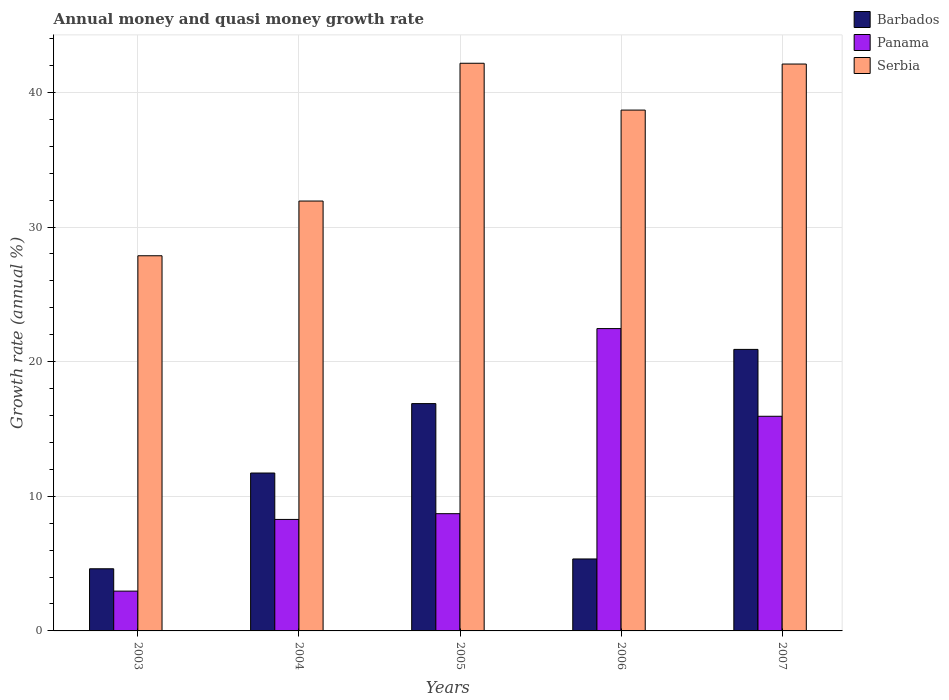How many bars are there on the 5th tick from the left?
Give a very brief answer. 3. In how many cases, is the number of bars for a given year not equal to the number of legend labels?
Offer a terse response. 0. What is the growth rate in Panama in 2006?
Ensure brevity in your answer.  22.46. Across all years, what is the maximum growth rate in Serbia?
Ensure brevity in your answer.  42.17. Across all years, what is the minimum growth rate in Panama?
Give a very brief answer. 2.96. In which year was the growth rate in Panama maximum?
Provide a succinct answer. 2006. In which year was the growth rate in Serbia minimum?
Ensure brevity in your answer.  2003. What is the total growth rate in Barbados in the graph?
Your answer should be very brief. 59.49. What is the difference between the growth rate in Barbados in 2004 and that in 2005?
Offer a very short reply. -5.16. What is the difference between the growth rate in Serbia in 2006 and the growth rate in Panama in 2004?
Your answer should be compact. 30.41. What is the average growth rate in Barbados per year?
Provide a short and direct response. 11.9. In the year 2005, what is the difference between the growth rate in Panama and growth rate in Serbia?
Give a very brief answer. -33.46. In how many years, is the growth rate in Serbia greater than 26 %?
Your answer should be very brief. 5. What is the ratio of the growth rate in Panama in 2004 to that in 2007?
Provide a succinct answer. 0.52. Is the difference between the growth rate in Panama in 2004 and 2005 greater than the difference between the growth rate in Serbia in 2004 and 2005?
Your response must be concise. Yes. What is the difference between the highest and the second highest growth rate in Serbia?
Offer a very short reply. 0.06. What is the difference between the highest and the lowest growth rate in Barbados?
Offer a terse response. 16.3. Is the sum of the growth rate in Barbados in 2003 and 2005 greater than the maximum growth rate in Serbia across all years?
Provide a succinct answer. No. What does the 1st bar from the left in 2005 represents?
Offer a very short reply. Barbados. What does the 1st bar from the right in 2003 represents?
Offer a very short reply. Serbia. Is it the case that in every year, the sum of the growth rate in Barbados and growth rate in Panama is greater than the growth rate in Serbia?
Offer a very short reply. No. How many bars are there?
Keep it short and to the point. 15. What is the difference between two consecutive major ticks on the Y-axis?
Make the answer very short. 10. Are the values on the major ticks of Y-axis written in scientific E-notation?
Your response must be concise. No. Does the graph contain grids?
Your answer should be very brief. Yes. Where does the legend appear in the graph?
Offer a very short reply. Top right. How many legend labels are there?
Your answer should be compact. 3. What is the title of the graph?
Ensure brevity in your answer.  Annual money and quasi money growth rate. What is the label or title of the Y-axis?
Offer a terse response. Growth rate (annual %). What is the Growth rate (annual %) of Barbados in 2003?
Keep it short and to the point. 4.62. What is the Growth rate (annual %) of Panama in 2003?
Offer a terse response. 2.96. What is the Growth rate (annual %) of Serbia in 2003?
Make the answer very short. 27.87. What is the Growth rate (annual %) in Barbados in 2004?
Provide a succinct answer. 11.73. What is the Growth rate (annual %) of Panama in 2004?
Make the answer very short. 8.28. What is the Growth rate (annual %) of Serbia in 2004?
Offer a terse response. 31.93. What is the Growth rate (annual %) in Barbados in 2005?
Provide a short and direct response. 16.89. What is the Growth rate (annual %) in Panama in 2005?
Ensure brevity in your answer.  8.71. What is the Growth rate (annual %) of Serbia in 2005?
Give a very brief answer. 42.17. What is the Growth rate (annual %) in Barbados in 2006?
Offer a terse response. 5.35. What is the Growth rate (annual %) of Panama in 2006?
Provide a succinct answer. 22.46. What is the Growth rate (annual %) of Serbia in 2006?
Give a very brief answer. 38.69. What is the Growth rate (annual %) in Barbados in 2007?
Provide a short and direct response. 20.91. What is the Growth rate (annual %) of Panama in 2007?
Make the answer very short. 15.95. What is the Growth rate (annual %) of Serbia in 2007?
Your answer should be very brief. 42.11. Across all years, what is the maximum Growth rate (annual %) of Barbados?
Offer a terse response. 20.91. Across all years, what is the maximum Growth rate (annual %) of Panama?
Your answer should be compact. 22.46. Across all years, what is the maximum Growth rate (annual %) in Serbia?
Your answer should be very brief. 42.17. Across all years, what is the minimum Growth rate (annual %) in Barbados?
Your answer should be compact. 4.62. Across all years, what is the minimum Growth rate (annual %) of Panama?
Your answer should be very brief. 2.96. Across all years, what is the minimum Growth rate (annual %) of Serbia?
Provide a succinct answer. 27.87. What is the total Growth rate (annual %) of Barbados in the graph?
Offer a terse response. 59.49. What is the total Growth rate (annual %) in Panama in the graph?
Offer a very short reply. 58.35. What is the total Growth rate (annual %) in Serbia in the graph?
Offer a terse response. 182.77. What is the difference between the Growth rate (annual %) of Barbados in 2003 and that in 2004?
Provide a short and direct response. -7.11. What is the difference between the Growth rate (annual %) in Panama in 2003 and that in 2004?
Provide a succinct answer. -5.33. What is the difference between the Growth rate (annual %) in Serbia in 2003 and that in 2004?
Give a very brief answer. -4.06. What is the difference between the Growth rate (annual %) in Barbados in 2003 and that in 2005?
Offer a very short reply. -12.27. What is the difference between the Growth rate (annual %) of Panama in 2003 and that in 2005?
Make the answer very short. -5.75. What is the difference between the Growth rate (annual %) of Serbia in 2003 and that in 2005?
Ensure brevity in your answer.  -14.3. What is the difference between the Growth rate (annual %) in Barbados in 2003 and that in 2006?
Provide a short and direct response. -0.73. What is the difference between the Growth rate (annual %) of Panama in 2003 and that in 2006?
Keep it short and to the point. -19.5. What is the difference between the Growth rate (annual %) in Serbia in 2003 and that in 2006?
Your response must be concise. -10.82. What is the difference between the Growth rate (annual %) in Barbados in 2003 and that in 2007?
Give a very brief answer. -16.3. What is the difference between the Growth rate (annual %) of Panama in 2003 and that in 2007?
Make the answer very short. -12.99. What is the difference between the Growth rate (annual %) in Serbia in 2003 and that in 2007?
Offer a very short reply. -14.24. What is the difference between the Growth rate (annual %) in Barbados in 2004 and that in 2005?
Provide a succinct answer. -5.16. What is the difference between the Growth rate (annual %) in Panama in 2004 and that in 2005?
Offer a terse response. -0.43. What is the difference between the Growth rate (annual %) in Serbia in 2004 and that in 2005?
Your answer should be compact. -10.23. What is the difference between the Growth rate (annual %) in Barbados in 2004 and that in 2006?
Make the answer very short. 6.38. What is the difference between the Growth rate (annual %) in Panama in 2004 and that in 2006?
Your answer should be very brief. -14.18. What is the difference between the Growth rate (annual %) of Serbia in 2004 and that in 2006?
Offer a terse response. -6.76. What is the difference between the Growth rate (annual %) in Barbados in 2004 and that in 2007?
Offer a terse response. -9.18. What is the difference between the Growth rate (annual %) of Panama in 2004 and that in 2007?
Your answer should be compact. -7.66. What is the difference between the Growth rate (annual %) of Serbia in 2004 and that in 2007?
Offer a very short reply. -10.18. What is the difference between the Growth rate (annual %) in Barbados in 2005 and that in 2006?
Keep it short and to the point. 11.54. What is the difference between the Growth rate (annual %) of Panama in 2005 and that in 2006?
Keep it short and to the point. -13.75. What is the difference between the Growth rate (annual %) in Serbia in 2005 and that in 2006?
Provide a succinct answer. 3.48. What is the difference between the Growth rate (annual %) of Barbados in 2005 and that in 2007?
Your answer should be very brief. -4.03. What is the difference between the Growth rate (annual %) in Panama in 2005 and that in 2007?
Make the answer very short. -7.24. What is the difference between the Growth rate (annual %) in Serbia in 2005 and that in 2007?
Provide a short and direct response. 0.06. What is the difference between the Growth rate (annual %) in Barbados in 2006 and that in 2007?
Your answer should be compact. -15.57. What is the difference between the Growth rate (annual %) in Panama in 2006 and that in 2007?
Your answer should be compact. 6.51. What is the difference between the Growth rate (annual %) in Serbia in 2006 and that in 2007?
Offer a terse response. -3.42. What is the difference between the Growth rate (annual %) of Barbados in 2003 and the Growth rate (annual %) of Panama in 2004?
Make the answer very short. -3.66. What is the difference between the Growth rate (annual %) in Barbados in 2003 and the Growth rate (annual %) in Serbia in 2004?
Keep it short and to the point. -27.32. What is the difference between the Growth rate (annual %) in Panama in 2003 and the Growth rate (annual %) in Serbia in 2004?
Provide a short and direct response. -28.98. What is the difference between the Growth rate (annual %) of Barbados in 2003 and the Growth rate (annual %) of Panama in 2005?
Keep it short and to the point. -4.09. What is the difference between the Growth rate (annual %) of Barbados in 2003 and the Growth rate (annual %) of Serbia in 2005?
Your answer should be compact. -37.55. What is the difference between the Growth rate (annual %) of Panama in 2003 and the Growth rate (annual %) of Serbia in 2005?
Give a very brief answer. -39.21. What is the difference between the Growth rate (annual %) in Barbados in 2003 and the Growth rate (annual %) in Panama in 2006?
Your answer should be very brief. -17.84. What is the difference between the Growth rate (annual %) in Barbados in 2003 and the Growth rate (annual %) in Serbia in 2006?
Your answer should be compact. -34.07. What is the difference between the Growth rate (annual %) in Panama in 2003 and the Growth rate (annual %) in Serbia in 2006?
Offer a very short reply. -35.73. What is the difference between the Growth rate (annual %) of Barbados in 2003 and the Growth rate (annual %) of Panama in 2007?
Provide a succinct answer. -11.33. What is the difference between the Growth rate (annual %) in Barbados in 2003 and the Growth rate (annual %) in Serbia in 2007?
Your answer should be very brief. -37.49. What is the difference between the Growth rate (annual %) in Panama in 2003 and the Growth rate (annual %) in Serbia in 2007?
Your answer should be compact. -39.15. What is the difference between the Growth rate (annual %) of Barbados in 2004 and the Growth rate (annual %) of Panama in 2005?
Give a very brief answer. 3.02. What is the difference between the Growth rate (annual %) in Barbados in 2004 and the Growth rate (annual %) in Serbia in 2005?
Offer a very short reply. -30.44. What is the difference between the Growth rate (annual %) of Panama in 2004 and the Growth rate (annual %) of Serbia in 2005?
Ensure brevity in your answer.  -33.89. What is the difference between the Growth rate (annual %) in Barbados in 2004 and the Growth rate (annual %) in Panama in 2006?
Your response must be concise. -10.73. What is the difference between the Growth rate (annual %) of Barbados in 2004 and the Growth rate (annual %) of Serbia in 2006?
Offer a terse response. -26.96. What is the difference between the Growth rate (annual %) in Panama in 2004 and the Growth rate (annual %) in Serbia in 2006?
Your answer should be compact. -30.41. What is the difference between the Growth rate (annual %) of Barbados in 2004 and the Growth rate (annual %) of Panama in 2007?
Your response must be concise. -4.22. What is the difference between the Growth rate (annual %) in Barbados in 2004 and the Growth rate (annual %) in Serbia in 2007?
Offer a very short reply. -30.38. What is the difference between the Growth rate (annual %) in Panama in 2004 and the Growth rate (annual %) in Serbia in 2007?
Keep it short and to the point. -33.83. What is the difference between the Growth rate (annual %) of Barbados in 2005 and the Growth rate (annual %) of Panama in 2006?
Your answer should be very brief. -5.57. What is the difference between the Growth rate (annual %) of Barbados in 2005 and the Growth rate (annual %) of Serbia in 2006?
Ensure brevity in your answer.  -21.8. What is the difference between the Growth rate (annual %) in Panama in 2005 and the Growth rate (annual %) in Serbia in 2006?
Ensure brevity in your answer.  -29.98. What is the difference between the Growth rate (annual %) in Barbados in 2005 and the Growth rate (annual %) in Panama in 2007?
Your response must be concise. 0.94. What is the difference between the Growth rate (annual %) of Barbados in 2005 and the Growth rate (annual %) of Serbia in 2007?
Give a very brief answer. -25.22. What is the difference between the Growth rate (annual %) in Panama in 2005 and the Growth rate (annual %) in Serbia in 2007?
Your answer should be compact. -33.4. What is the difference between the Growth rate (annual %) in Barbados in 2006 and the Growth rate (annual %) in Panama in 2007?
Make the answer very short. -10.6. What is the difference between the Growth rate (annual %) of Barbados in 2006 and the Growth rate (annual %) of Serbia in 2007?
Your answer should be very brief. -36.76. What is the difference between the Growth rate (annual %) in Panama in 2006 and the Growth rate (annual %) in Serbia in 2007?
Your answer should be compact. -19.65. What is the average Growth rate (annual %) in Barbados per year?
Give a very brief answer. 11.9. What is the average Growth rate (annual %) of Panama per year?
Ensure brevity in your answer.  11.67. What is the average Growth rate (annual %) of Serbia per year?
Provide a short and direct response. 36.55. In the year 2003, what is the difference between the Growth rate (annual %) in Barbados and Growth rate (annual %) in Panama?
Provide a succinct answer. 1.66. In the year 2003, what is the difference between the Growth rate (annual %) in Barbados and Growth rate (annual %) in Serbia?
Make the answer very short. -23.25. In the year 2003, what is the difference between the Growth rate (annual %) in Panama and Growth rate (annual %) in Serbia?
Provide a short and direct response. -24.91. In the year 2004, what is the difference between the Growth rate (annual %) in Barbados and Growth rate (annual %) in Panama?
Offer a terse response. 3.45. In the year 2004, what is the difference between the Growth rate (annual %) in Barbados and Growth rate (annual %) in Serbia?
Offer a very short reply. -20.2. In the year 2004, what is the difference between the Growth rate (annual %) of Panama and Growth rate (annual %) of Serbia?
Give a very brief answer. -23.65. In the year 2005, what is the difference between the Growth rate (annual %) in Barbados and Growth rate (annual %) in Panama?
Your response must be concise. 8.18. In the year 2005, what is the difference between the Growth rate (annual %) in Barbados and Growth rate (annual %) in Serbia?
Provide a succinct answer. -25.28. In the year 2005, what is the difference between the Growth rate (annual %) in Panama and Growth rate (annual %) in Serbia?
Keep it short and to the point. -33.46. In the year 2006, what is the difference between the Growth rate (annual %) in Barbados and Growth rate (annual %) in Panama?
Provide a short and direct response. -17.11. In the year 2006, what is the difference between the Growth rate (annual %) in Barbados and Growth rate (annual %) in Serbia?
Provide a short and direct response. -33.34. In the year 2006, what is the difference between the Growth rate (annual %) in Panama and Growth rate (annual %) in Serbia?
Offer a very short reply. -16.23. In the year 2007, what is the difference between the Growth rate (annual %) of Barbados and Growth rate (annual %) of Panama?
Make the answer very short. 4.97. In the year 2007, what is the difference between the Growth rate (annual %) of Barbados and Growth rate (annual %) of Serbia?
Keep it short and to the point. -21.2. In the year 2007, what is the difference between the Growth rate (annual %) of Panama and Growth rate (annual %) of Serbia?
Give a very brief answer. -26.16. What is the ratio of the Growth rate (annual %) of Barbados in 2003 to that in 2004?
Your answer should be very brief. 0.39. What is the ratio of the Growth rate (annual %) of Panama in 2003 to that in 2004?
Give a very brief answer. 0.36. What is the ratio of the Growth rate (annual %) of Serbia in 2003 to that in 2004?
Ensure brevity in your answer.  0.87. What is the ratio of the Growth rate (annual %) of Barbados in 2003 to that in 2005?
Keep it short and to the point. 0.27. What is the ratio of the Growth rate (annual %) of Panama in 2003 to that in 2005?
Ensure brevity in your answer.  0.34. What is the ratio of the Growth rate (annual %) of Serbia in 2003 to that in 2005?
Provide a succinct answer. 0.66. What is the ratio of the Growth rate (annual %) in Barbados in 2003 to that in 2006?
Offer a very short reply. 0.86. What is the ratio of the Growth rate (annual %) in Panama in 2003 to that in 2006?
Your answer should be compact. 0.13. What is the ratio of the Growth rate (annual %) in Serbia in 2003 to that in 2006?
Provide a short and direct response. 0.72. What is the ratio of the Growth rate (annual %) in Barbados in 2003 to that in 2007?
Your answer should be very brief. 0.22. What is the ratio of the Growth rate (annual %) in Panama in 2003 to that in 2007?
Ensure brevity in your answer.  0.19. What is the ratio of the Growth rate (annual %) of Serbia in 2003 to that in 2007?
Your answer should be compact. 0.66. What is the ratio of the Growth rate (annual %) of Barbados in 2004 to that in 2005?
Offer a terse response. 0.69. What is the ratio of the Growth rate (annual %) in Panama in 2004 to that in 2005?
Your answer should be very brief. 0.95. What is the ratio of the Growth rate (annual %) of Serbia in 2004 to that in 2005?
Provide a succinct answer. 0.76. What is the ratio of the Growth rate (annual %) in Barbados in 2004 to that in 2006?
Make the answer very short. 2.19. What is the ratio of the Growth rate (annual %) in Panama in 2004 to that in 2006?
Ensure brevity in your answer.  0.37. What is the ratio of the Growth rate (annual %) in Serbia in 2004 to that in 2006?
Provide a succinct answer. 0.83. What is the ratio of the Growth rate (annual %) in Barbados in 2004 to that in 2007?
Keep it short and to the point. 0.56. What is the ratio of the Growth rate (annual %) of Panama in 2004 to that in 2007?
Ensure brevity in your answer.  0.52. What is the ratio of the Growth rate (annual %) in Serbia in 2004 to that in 2007?
Provide a succinct answer. 0.76. What is the ratio of the Growth rate (annual %) of Barbados in 2005 to that in 2006?
Your response must be concise. 3.16. What is the ratio of the Growth rate (annual %) of Panama in 2005 to that in 2006?
Make the answer very short. 0.39. What is the ratio of the Growth rate (annual %) in Serbia in 2005 to that in 2006?
Your response must be concise. 1.09. What is the ratio of the Growth rate (annual %) in Barbados in 2005 to that in 2007?
Offer a very short reply. 0.81. What is the ratio of the Growth rate (annual %) of Panama in 2005 to that in 2007?
Ensure brevity in your answer.  0.55. What is the ratio of the Growth rate (annual %) in Barbados in 2006 to that in 2007?
Provide a short and direct response. 0.26. What is the ratio of the Growth rate (annual %) of Panama in 2006 to that in 2007?
Offer a very short reply. 1.41. What is the ratio of the Growth rate (annual %) of Serbia in 2006 to that in 2007?
Provide a short and direct response. 0.92. What is the difference between the highest and the second highest Growth rate (annual %) of Barbados?
Offer a terse response. 4.03. What is the difference between the highest and the second highest Growth rate (annual %) of Panama?
Ensure brevity in your answer.  6.51. What is the difference between the highest and the second highest Growth rate (annual %) of Serbia?
Your answer should be very brief. 0.06. What is the difference between the highest and the lowest Growth rate (annual %) in Barbados?
Give a very brief answer. 16.3. What is the difference between the highest and the lowest Growth rate (annual %) in Panama?
Offer a terse response. 19.5. What is the difference between the highest and the lowest Growth rate (annual %) in Serbia?
Your response must be concise. 14.3. 